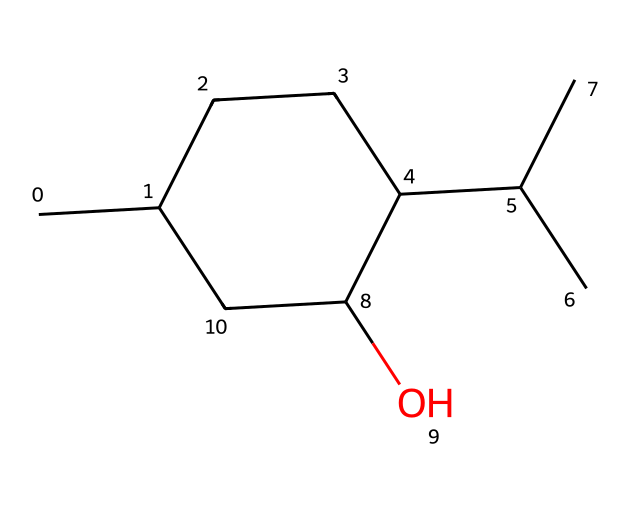What is the chemical name of this compound? The SMILES representation indicates the presence of a cyclic structure (noted by 'C1' with a closing 'C1') and the hydroxyl group (O). Analyzing the structure shows it corresponds to menthol, which is known for its soothing effects.
Answer: menthol How many carbon atoms are in this structure? The SMILES representation indicates there are 10 carbon atoms (C) in total by counting each 'C' in the structure while considering the branching and cyclic nature.
Answer: 10 Is this compound saturated or unsaturated? By examining the structure, we can see that all carbon-carbon bonds are single bonds, with no double bonds present. This indicates that the compound is saturated.
Answer: saturated How many rings does this molecule contain? The presence of 'C1' and the corresponding 'C1' at the end of the SMILES indicates a single cyclic structure, representing one ring in the molecule.
Answer: 1 What functional group is present in menthol? The presence of 'C(O)' in the SMILES indicates that there is a hydroxyl group (-OH), which is the functional group in menthol that contributes to its characteristics.
Answer: hydroxyl group What type of cycloalkane is menthol classified as? Analyzing the structure shows that menthol is a cyclic structure with all single bonds and one hydroxyl group, classifying it as a cycloalkanol due to the presence of the alcohol functional group.
Answer: cycloalkanol Does menthol contain any chiral centers? In the structure, the carbon atoms are examined, and there is a carbon connected to four different substituents, indicating a chiral center present in menthol.
Answer: yes 